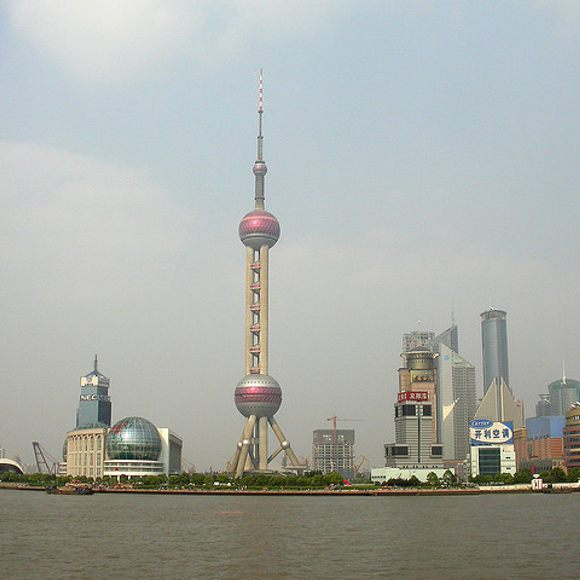What do you see happening in this image? The image showcases the iconic Oriental Pearl Tower, a prominent landmark in Shanghai, China. The tower is characterized by its unique design, featuring three large spheres that vary in size, connected by cylindrical columns. The middle sphere is the largest, with a smaller sphere above it and another, even smaller, near its base. The entire structure has a striking pink and silver color scheme and is crowned with a spire reaching into the hazy sky. Surrounding the tower is a bustling urban landscape full of modern skyscrapers and buildings, which highlights the city’s architectural diversity. A river flows nearby, adding a peaceful element to the vibrant cityscape. The photograph captures the grandeur of the tower and its significance as a symbol of Shanghai’s skyline. 